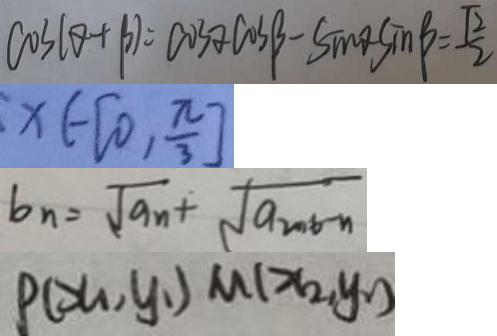Convert formula to latex. <formula><loc_0><loc_0><loc_500><loc_500>\cos ( \theta + \beta ) = \cos \alpha \cos \beta - \sin \theta \sin \beta = \frac { \sqrt { 2 } } { 2 } 
 x \in [ 0 , \frac { \pi } { 3 } ] 
 b _ { n } = \sqrt { a _ { n } } + \sqrt { a _ { 2 0 0 6 } - n } 
 P ( x _ { 1 } , y _ { 1 } ) M ( x _ { 2 } , y _ { 2 } )</formula> 